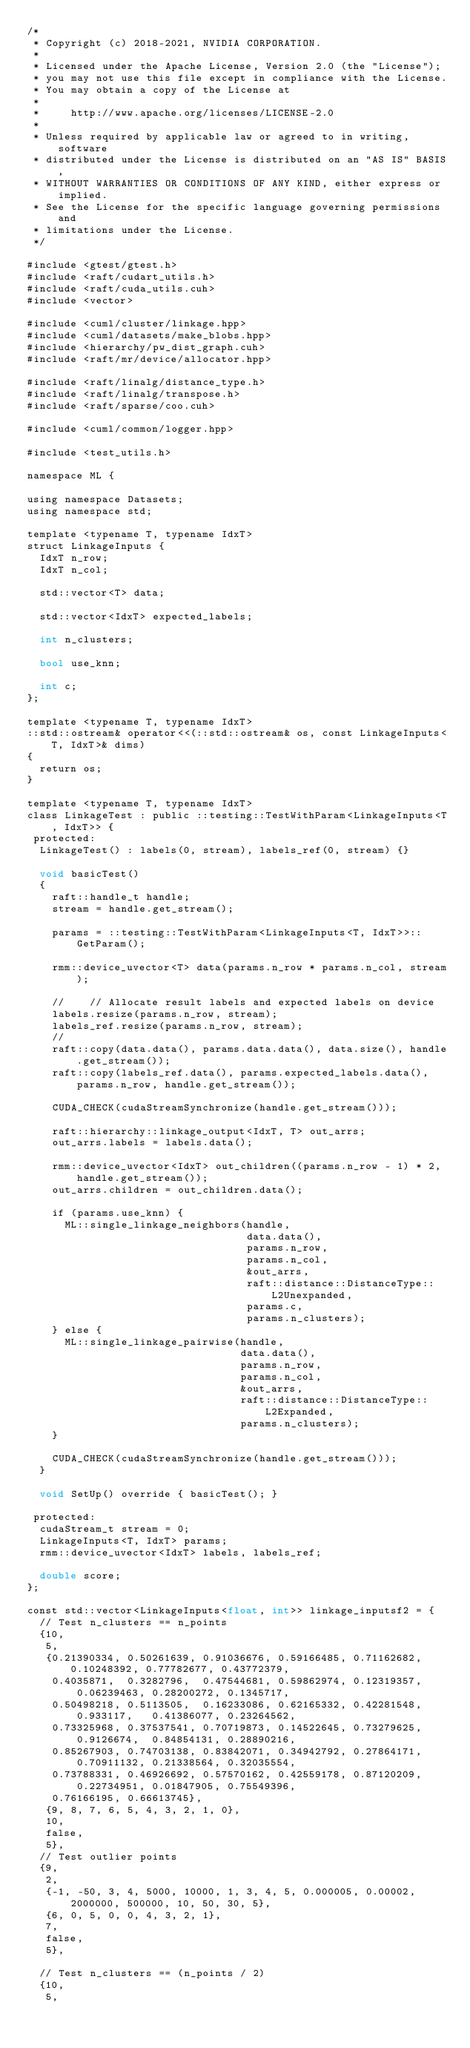<code> <loc_0><loc_0><loc_500><loc_500><_Cuda_>/*
 * Copyright (c) 2018-2021, NVIDIA CORPORATION.
 *
 * Licensed under the Apache License, Version 2.0 (the "License");
 * you may not use this file except in compliance with the License.
 * You may obtain a copy of the License at
 *
 *     http://www.apache.org/licenses/LICENSE-2.0
 *
 * Unless required by applicable law or agreed to in writing, software
 * distributed under the License is distributed on an "AS IS" BASIS,
 * WITHOUT WARRANTIES OR CONDITIONS OF ANY KIND, either express or implied.
 * See the License for the specific language governing permissions and
 * limitations under the License.
 */

#include <gtest/gtest.h>
#include <raft/cudart_utils.h>
#include <raft/cuda_utils.cuh>
#include <vector>

#include <cuml/cluster/linkage.hpp>
#include <cuml/datasets/make_blobs.hpp>
#include <hierarchy/pw_dist_graph.cuh>
#include <raft/mr/device/allocator.hpp>

#include <raft/linalg/distance_type.h>
#include <raft/linalg/transpose.h>
#include <raft/sparse/coo.cuh>

#include <cuml/common/logger.hpp>

#include <test_utils.h>

namespace ML {

using namespace Datasets;
using namespace std;

template <typename T, typename IdxT>
struct LinkageInputs {
  IdxT n_row;
  IdxT n_col;

  std::vector<T> data;

  std::vector<IdxT> expected_labels;

  int n_clusters;

  bool use_knn;

  int c;
};

template <typename T, typename IdxT>
::std::ostream& operator<<(::std::ostream& os, const LinkageInputs<T, IdxT>& dims)
{
  return os;
}

template <typename T, typename IdxT>
class LinkageTest : public ::testing::TestWithParam<LinkageInputs<T, IdxT>> {
 protected:
  LinkageTest() : labels(0, stream), labels_ref(0, stream) {}

  void basicTest()
  {
    raft::handle_t handle;
    stream = handle.get_stream();

    params = ::testing::TestWithParam<LinkageInputs<T, IdxT>>::GetParam();

    rmm::device_uvector<T> data(params.n_row * params.n_col, stream);

    //    // Allocate result labels and expected labels on device
    labels.resize(params.n_row, stream);
    labels_ref.resize(params.n_row, stream);
    //
    raft::copy(data.data(), params.data.data(), data.size(), handle.get_stream());
    raft::copy(labels_ref.data(), params.expected_labels.data(), params.n_row, handle.get_stream());

    CUDA_CHECK(cudaStreamSynchronize(handle.get_stream()));

    raft::hierarchy::linkage_output<IdxT, T> out_arrs;
    out_arrs.labels = labels.data();

    rmm::device_uvector<IdxT> out_children((params.n_row - 1) * 2, handle.get_stream());
    out_arrs.children = out_children.data();

    if (params.use_knn) {
      ML::single_linkage_neighbors(handle,
                                   data.data(),
                                   params.n_row,
                                   params.n_col,
                                   &out_arrs,
                                   raft::distance::DistanceType::L2Unexpanded,
                                   params.c,
                                   params.n_clusters);
    } else {
      ML::single_linkage_pairwise(handle,
                                  data.data(),
                                  params.n_row,
                                  params.n_col,
                                  &out_arrs,
                                  raft::distance::DistanceType::L2Expanded,
                                  params.n_clusters);
    }

    CUDA_CHECK(cudaStreamSynchronize(handle.get_stream()));
  }

  void SetUp() override { basicTest(); }

 protected:
  cudaStream_t stream = 0;
  LinkageInputs<T, IdxT> params;
  rmm::device_uvector<IdxT> labels, labels_ref;

  double score;
};

const std::vector<LinkageInputs<float, int>> linkage_inputsf2 = {
  // Test n_clusters == n_points
  {10,
   5,
   {0.21390334, 0.50261639, 0.91036676, 0.59166485, 0.71162682, 0.10248392, 0.77782677, 0.43772379,
    0.4035871,  0.3282796,  0.47544681, 0.59862974, 0.12319357, 0.06239463, 0.28200272, 0.1345717,
    0.50498218, 0.5113505,  0.16233086, 0.62165332, 0.42281548, 0.933117,   0.41386077, 0.23264562,
    0.73325968, 0.37537541, 0.70719873, 0.14522645, 0.73279625, 0.9126674,  0.84854131, 0.28890216,
    0.85267903, 0.74703138, 0.83842071, 0.34942792, 0.27864171, 0.70911132, 0.21338564, 0.32035554,
    0.73788331, 0.46926692, 0.57570162, 0.42559178, 0.87120209, 0.22734951, 0.01847905, 0.75549396,
    0.76166195, 0.66613745},
   {9, 8, 7, 6, 5, 4, 3, 2, 1, 0},
   10,
   false,
   5},
  // Test outlier points
  {9,
   2,
   {-1, -50, 3, 4, 5000, 10000, 1, 3, 4, 5, 0.000005, 0.00002, 2000000, 500000, 10, 50, 30, 5},
   {6, 0, 5, 0, 0, 4, 3, 2, 1},
   7,
   false,
   5},

  // Test n_clusters == (n_points / 2)
  {10,
   5,</code> 